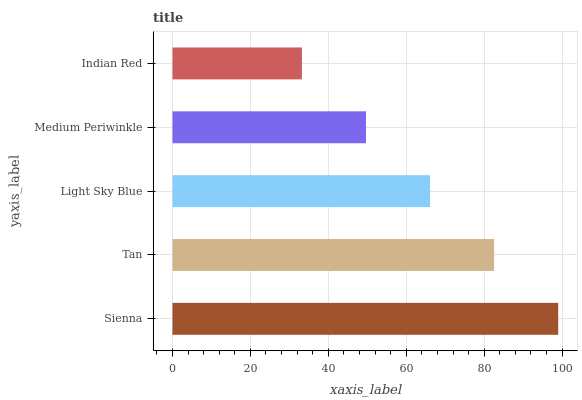Is Indian Red the minimum?
Answer yes or no. Yes. Is Sienna the maximum?
Answer yes or no. Yes. Is Tan the minimum?
Answer yes or no. No. Is Tan the maximum?
Answer yes or no. No. Is Sienna greater than Tan?
Answer yes or no. Yes. Is Tan less than Sienna?
Answer yes or no. Yes. Is Tan greater than Sienna?
Answer yes or no. No. Is Sienna less than Tan?
Answer yes or no. No. Is Light Sky Blue the high median?
Answer yes or no. Yes. Is Light Sky Blue the low median?
Answer yes or no. Yes. Is Tan the high median?
Answer yes or no. No. Is Medium Periwinkle the low median?
Answer yes or no. No. 